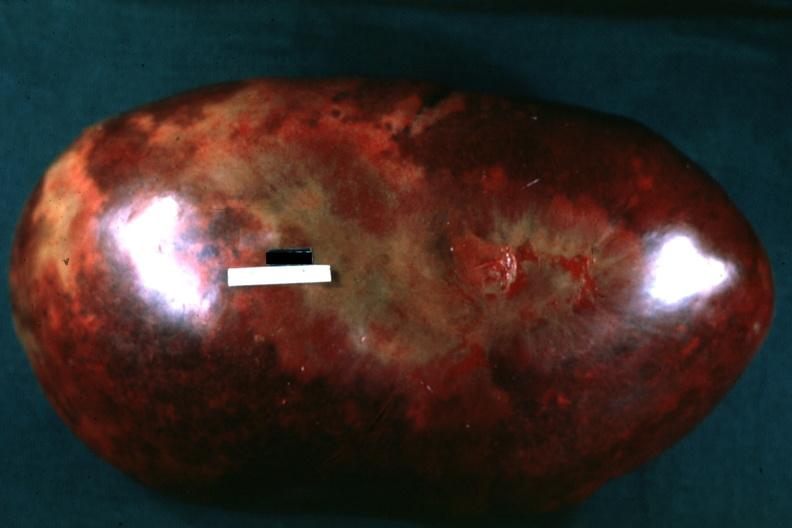s spleen present?
Answer the question using a single word or phrase. Yes 